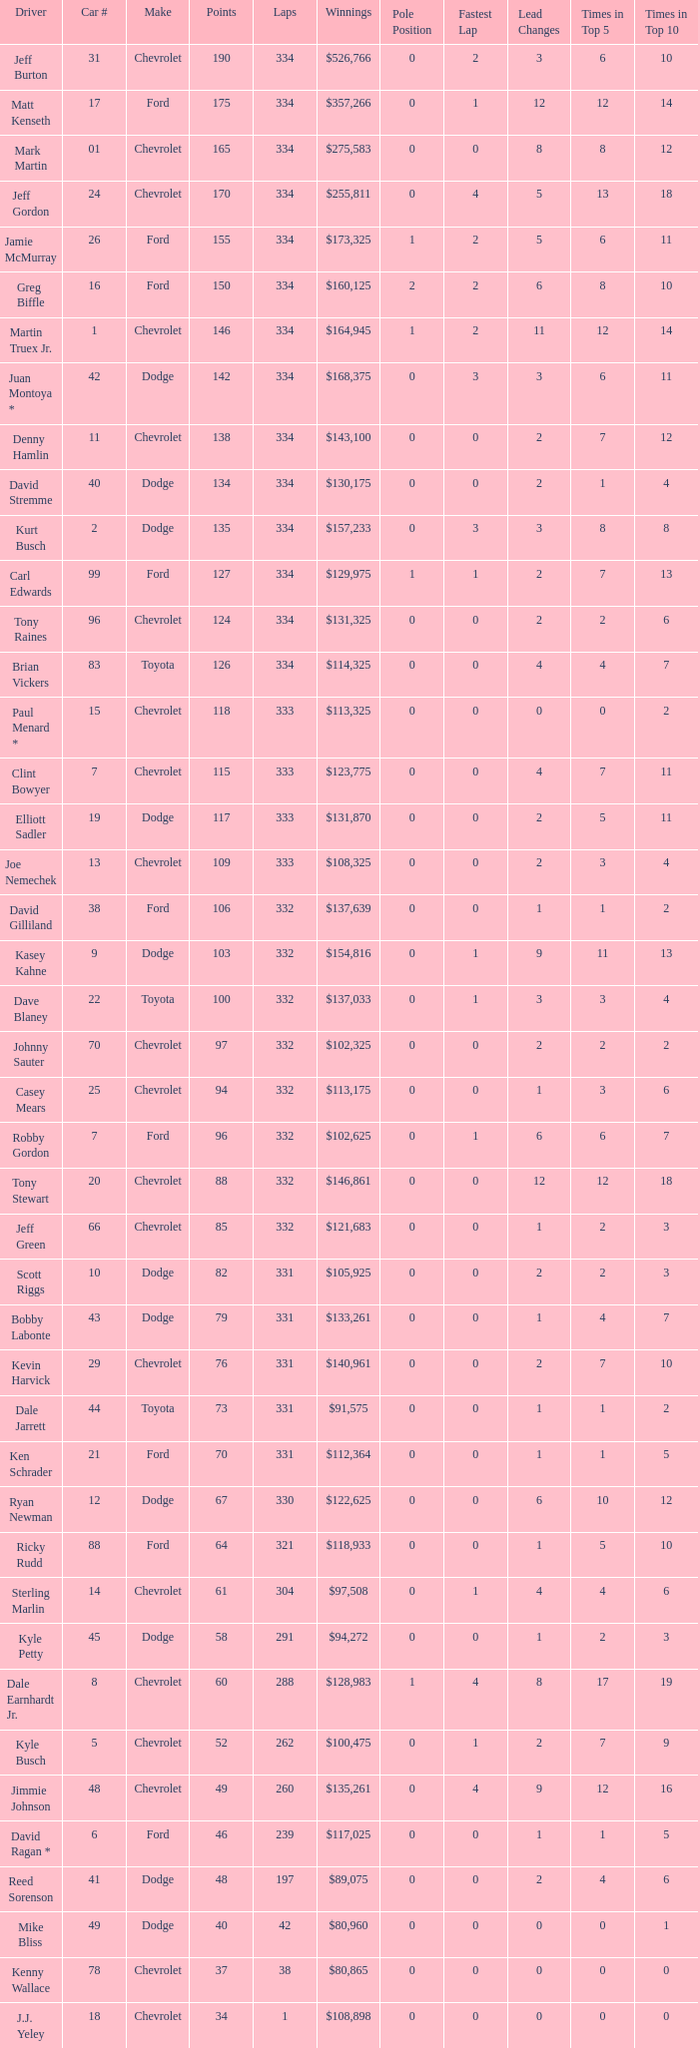How many total laps did the Chevrolet that won $97,508 make? 1.0. 